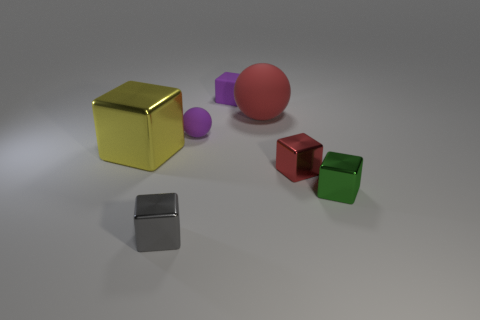How many objects are either metal objects to the left of the small purple block or cubes that are right of the tiny red metal object? In the image, there is one metal object to the left of the small purple block and two cubes to the right of the tiny red metal object, making a total of three objects meeting the criteria. 